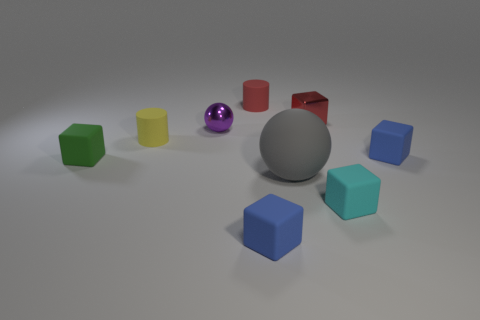Subtract all red blocks. How many blocks are left? 4 Subtract 1 cubes. How many cubes are left? 4 Subtract all small cyan cubes. How many cubes are left? 4 Subtract all cyan blocks. Subtract all green cylinders. How many blocks are left? 4 Add 1 tiny cyan cubes. How many objects exist? 10 Subtract 0 purple cylinders. How many objects are left? 9 Subtract all cubes. How many objects are left? 4 Subtract all red matte objects. Subtract all tiny objects. How many objects are left? 0 Add 6 tiny blue matte objects. How many tiny blue matte objects are left? 8 Add 5 tiny blue blocks. How many tiny blue blocks exist? 7 